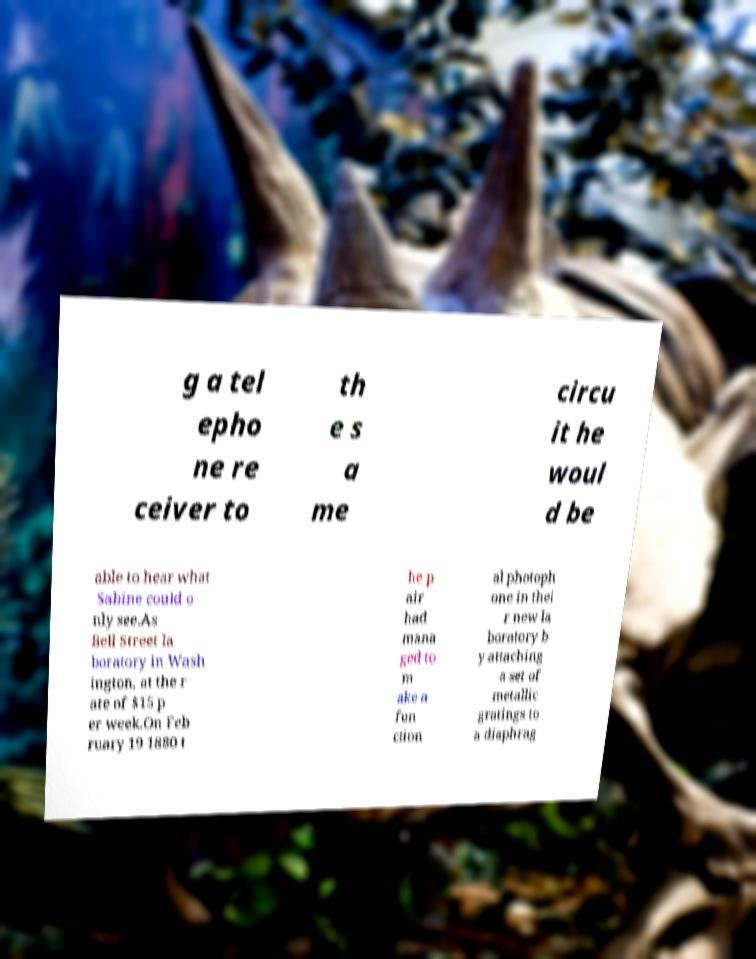What messages or text are displayed in this image? I need them in a readable, typed format. g a tel epho ne re ceiver to th e s a me circu it he woul d be able to hear what Sabine could o nly see.As Bell Street la boratory in Wash ington, at the r ate of $15 p er week.On Feb ruary 19 1880 t he p air had mana ged to m ake a fun ction al photoph one in thei r new la boratory b y attaching a set of metallic gratings to a diaphrag 